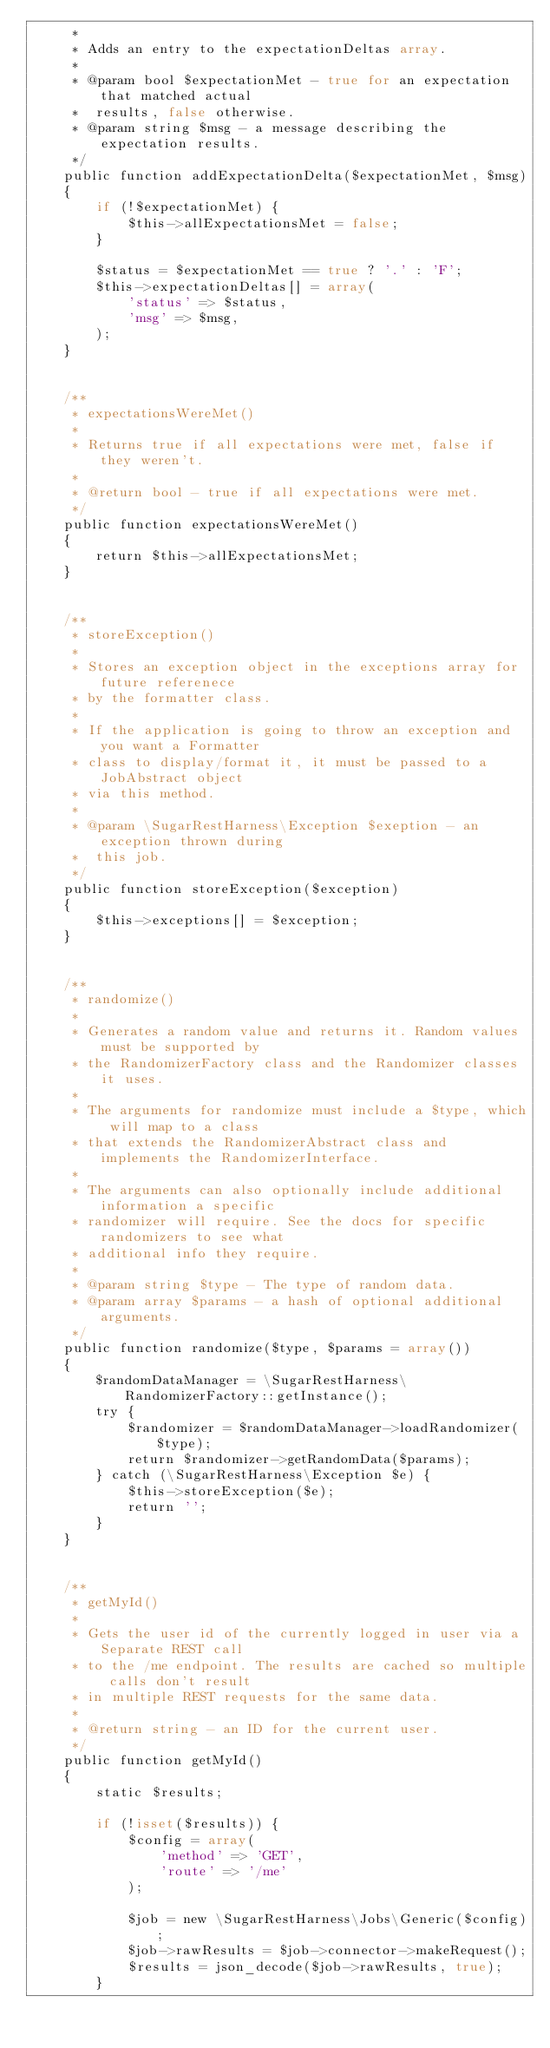<code> <loc_0><loc_0><loc_500><loc_500><_PHP_>     *
     * Adds an entry to the expectationDeltas array.
     *
     * @param bool $expectationMet - true for an expectation that matched actual 
     *  results, false otherwise.
     * @param string $msg - a message describing the expectation results.
     */
    public function addExpectationDelta($expectationMet, $msg)
    {
        if (!$expectationMet) {
            $this->allExpectationsMet = false;
        }
        
        $status = $expectationMet == true ? '.' : 'F';
        $this->expectationDeltas[] = array(
            'status' => $status,
            'msg' => $msg,
        );
    }
    
    
    /**
     * expectationsWereMet()
     *
     * Returns true if all expectations were met, false if they weren't.
     *
     * @return bool - true if all expectations were met.
     */
    public function expectationsWereMet()
    {
        return $this->allExpectationsMet;
    }
    
    
    /**
     * storeException()
     *
     * Stores an exception object in the exceptions array for future referenece
     * by the formatter class.
     *
     * If the application is going to throw an exception and you want a Formatter
     * class to display/format it, it must be passed to a JobAbstract object
     * via this method.
     *
     * @param \SugarRestHarness\Exception $exeption - an exception thrown during
     *  this job.
     */
    public function storeException($exception)
    {
        $this->exceptions[] = $exception;
    }
    
    
    /**
     * randomize()
     *
     * Generates a random value and returns it. Random values must be supported by
     * the RandomizerFactory class and the Randomizer classes it uses.
     *
     * The arguments for randomize must include a $type, which will map to a class
     * that extends the RandomizerAbstract class and implements the RandomizerInterface.
     *
     * The arguments can also optionally include additional information a specific
     * randomizer will require. See the docs for specific randomizers to see what
     * additional info they require.
     *
     * @param string $type - The type of random data.
     * @param array $params - a hash of optional additional arguments.
     */
    public function randomize($type, $params = array())
    {
        $randomDataManager = \SugarRestHarness\RandomizerFactory::getInstance();
        try {
            $randomizer = $randomDataManager->loadRandomizer($type);
            return $randomizer->getRandomData($params);
        } catch (\SugarRestHarness\Exception $e) {
            $this->storeException($e);
            return '';
        }
    }
    
    
    /**
     * getMyId()
     *
     * Gets the user id of the currently logged in user via a Separate REST call
     * to the /me endpoint. The results are cached so multiple calls don't result
     * in multiple REST requests for the same data.
     *
     * @return string - an ID for the current user.
     */
    public function getMyId()
    {
        static $results;
        
        if (!isset($results)) {
            $config = array(
                'method' => 'GET',
                'route' => '/me'
            );
        
            $job = new \SugarRestHarness\Jobs\Generic($config);
            $job->rawResults = $job->connector->makeRequest();
            $results = json_decode($job->rawResults, true);
        }</code> 